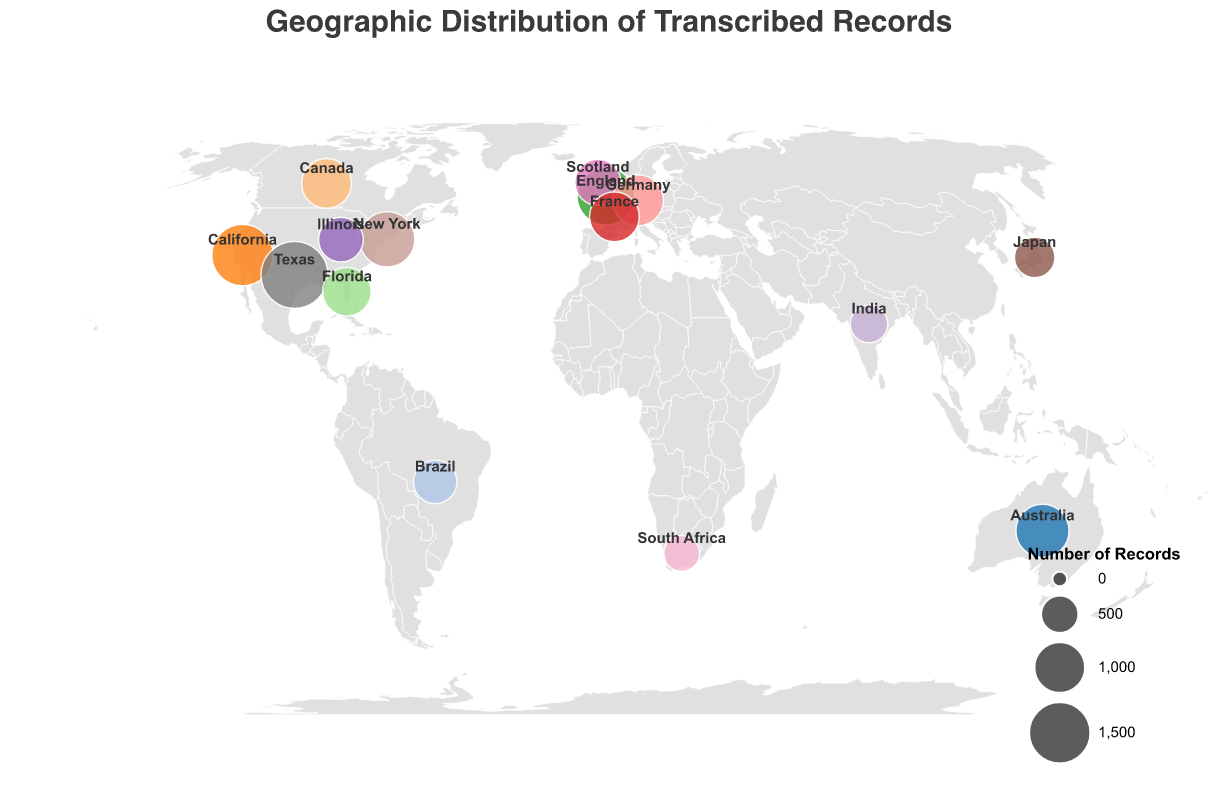What is the title of the figure? The title of the figure is usually placed at the top and gives a quick idea of what the figure is about. The given title can be directly read from the figure.
Answer: Geographic Distribution of Transcribed Records Which location has the largest bubble? The size of the bubble represents the number of records, so the largest bubble indicates the location with the highest records, which can be identified by comparing the bubble sizes visually.
Answer: Texas Which location has a higher number of records: New York or California? You can compare the sizes of bubbles for New York and California. New York's bubble represents 1200 records while California's bubble represents 1500 records.
Answer: California What information is shown by the tooltip for each bubble? The tooltip typically provides details when you hover over a bubble in the figure. According to the given details, it shows the location name and the number of records.
Answer: Location and number of records What is the average number of records for the states/countries listed? To find the average, sum all the number of records for each state/country and divide by the total number of locations: (1500 + 1200 + 1800 + 900 + 750 + 1300 + 800 + 950 + 1100 + 1000 + 950 + 500 + 600 + 700 + 450) / 15 = 14500 / 15 = 966.67
Answer: 966.67 What is the difference in the number of records between the location with the most records and the location with the fewest records? The location with the most records is Texas (1800), and the location with the fewest records is South Africa (450). The difference is 1800 - 450 = 1350.
Answer: 1350 Which continent has the highest combined number of records, and what is that number? To find the continent with the highest combined number of records, sum the records of each country within the continent. In North America: California (1500), New York (1200), Texas (1800), Florida (900), Illinois (750) and Canada (950). The combined number is 1500 + 1200 + 1800 + 900 + 750 + 950 = 7100.
Answer: North America, 7100 What geographic feature is used for plotting the locations of records? Each bubble represents a location and is plotted using the geographical coordinates (latitude and longitude) provided for each state/country.
Answer: Latitude and Longitude Identify the countries with less than 800 records. Bubbles with sizes proportional to the number of records will be compared. Countries with less than 800 records are India (500), Japan (600), Brazil (700), and South Africa (450).
Answer: India, Japan, Brazil, South Africa 